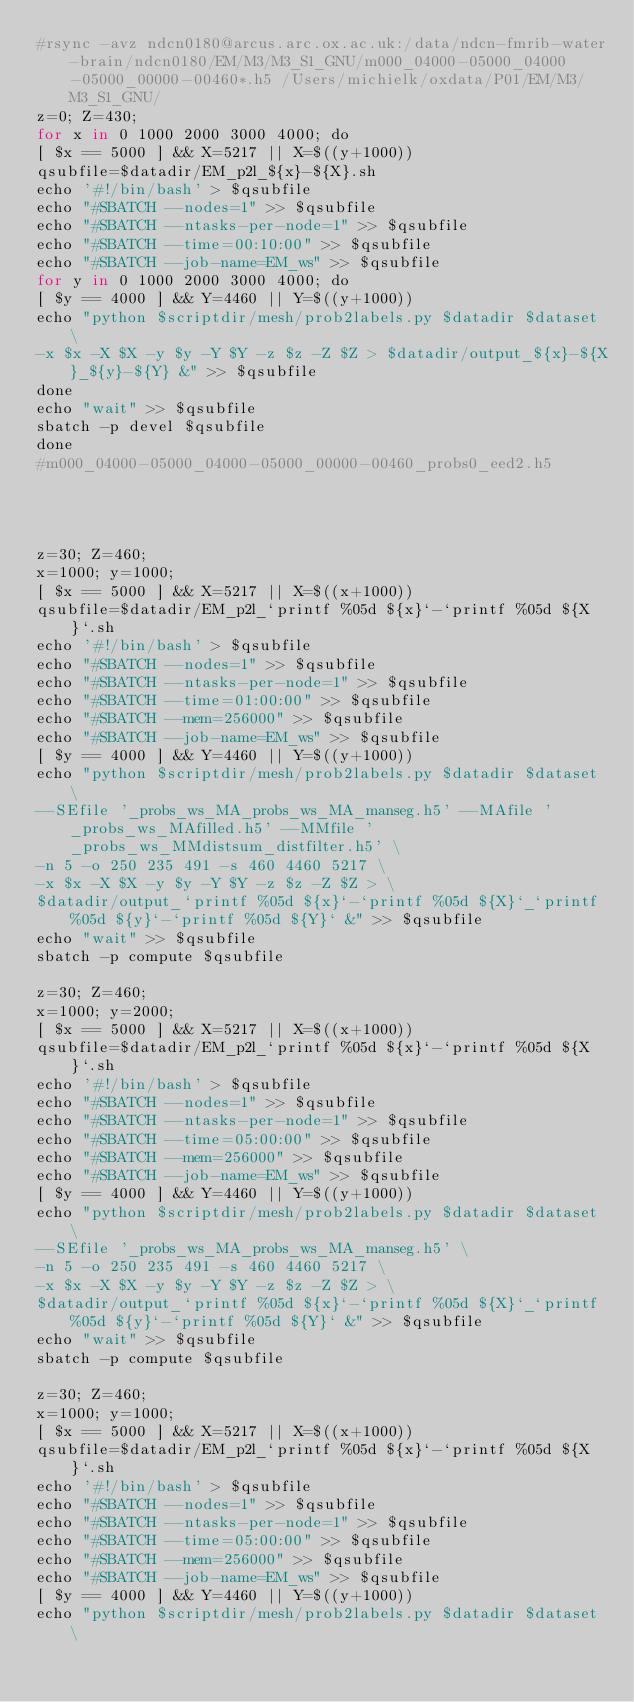<code> <loc_0><loc_0><loc_500><loc_500><_Python_>#rsync -avz ndcn0180@arcus.arc.ox.ac.uk:/data/ndcn-fmrib-water-brain/ndcn0180/EM/M3/M3_S1_GNU/m000_04000-05000_04000-05000_00000-00460*.h5 /Users/michielk/oxdata/P01/EM/M3/M3_S1_GNU/
z=0; Z=430;
for x in 0 1000 2000 3000 4000; do
[ $x == 5000 ] && X=5217 || X=$((y+1000))
qsubfile=$datadir/EM_p2l_${x}-${X}.sh
echo '#!/bin/bash' > $qsubfile
echo "#SBATCH --nodes=1" >> $qsubfile
echo "#SBATCH --ntasks-per-node=1" >> $qsubfile
echo "#SBATCH --time=00:10:00" >> $qsubfile
echo "#SBATCH --job-name=EM_ws" >> $qsubfile
for y in 0 1000 2000 3000 4000; do
[ $y == 4000 ] && Y=4460 || Y=$((y+1000))
echo "python $scriptdir/mesh/prob2labels.py $datadir $dataset \
-x $x -X $X -y $y -Y $Y -z $z -Z $Z > $datadir/output_${x}-${X}_${y}-${Y} &" >> $qsubfile
done
echo "wait" >> $qsubfile
sbatch -p devel $qsubfile
done
#m000_04000-05000_04000-05000_00000-00460_probs0_eed2.h5




z=30; Z=460;
x=1000; y=1000;
[ $x == 5000 ] && X=5217 || X=$((x+1000))
qsubfile=$datadir/EM_p2l_`printf %05d ${x}`-`printf %05d ${X}`.sh
echo '#!/bin/bash' > $qsubfile
echo "#SBATCH --nodes=1" >> $qsubfile
echo "#SBATCH --ntasks-per-node=1" >> $qsubfile
echo "#SBATCH --time=01:00:00" >> $qsubfile
echo "#SBATCH --mem=256000" >> $qsubfile
echo "#SBATCH --job-name=EM_ws" >> $qsubfile
[ $y == 4000 ] && Y=4460 || Y=$((y+1000))
echo "python $scriptdir/mesh/prob2labels.py $datadir $dataset \
--SEfile '_probs_ws_MA_probs_ws_MA_manseg.h5' --MAfile '_probs_ws_MAfilled.h5' --MMfile '_probs_ws_MMdistsum_distfilter.h5' \
-n 5 -o 250 235 491 -s 460 4460 5217 \
-x $x -X $X -y $y -Y $Y -z $z -Z $Z > \
$datadir/output_`printf %05d ${x}`-`printf %05d ${X}`_`printf %05d ${y}`-`printf %05d ${Y}` &" >> $qsubfile
echo "wait" >> $qsubfile
sbatch -p compute $qsubfile

z=30; Z=460;
x=1000; y=2000;
[ $x == 5000 ] && X=5217 || X=$((x+1000))
qsubfile=$datadir/EM_p2l_`printf %05d ${x}`-`printf %05d ${X}`.sh
echo '#!/bin/bash' > $qsubfile
echo "#SBATCH --nodes=1" >> $qsubfile
echo "#SBATCH --ntasks-per-node=1" >> $qsubfile
echo "#SBATCH --time=05:00:00" >> $qsubfile
echo "#SBATCH --mem=256000" >> $qsubfile
echo "#SBATCH --job-name=EM_ws" >> $qsubfile
[ $y == 4000 ] && Y=4460 || Y=$((y+1000))
echo "python $scriptdir/mesh/prob2labels.py $datadir $dataset \
--SEfile '_probs_ws_MA_probs_ws_MA_manseg.h5' \
-n 5 -o 250 235 491 -s 460 4460 5217 \
-x $x -X $X -y $y -Y $Y -z $z -Z $Z > \
$datadir/output_`printf %05d ${x}`-`printf %05d ${X}`_`printf %05d ${y}`-`printf %05d ${Y}` &" >> $qsubfile
echo "wait" >> $qsubfile
sbatch -p compute $qsubfile

z=30; Z=460;
x=1000; y=1000;
[ $x == 5000 ] && X=5217 || X=$((x+1000))
qsubfile=$datadir/EM_p2l_`printf %05d ${x}`-`printf %05d ${X}`.sh
echo '#!/bin/bash' > $qsubfile
echo "#SBATCH --nodes=1" >> $qsubfile
echo "#SBATCH --ntasks-per-node=1" >> $qsubfile
echo "#SBATCH --time=05:00:00" >> $qsubfile
echo "#SBATCH --mem=256000" >> $qsubfile
echo "#SBATCH --job-name=EM_ws" >> $qsubfile
[ $y == 4000 ] && Y=4460 || Y=$((y+1000))
echo "python $scriptdir/mesh/prob2labels.py $datadir $dataset \</code> 